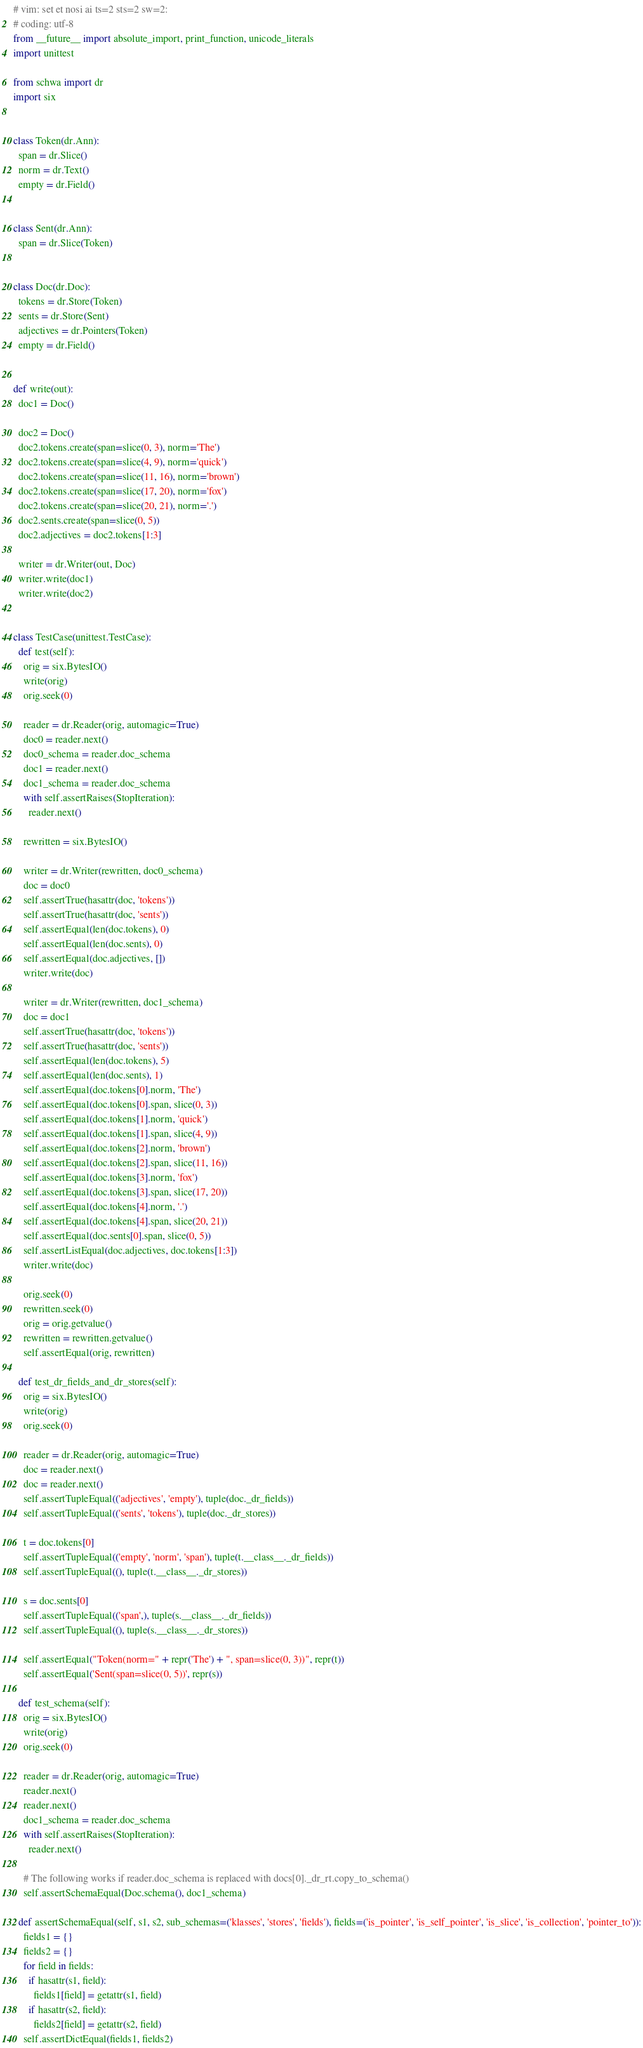Convert code to text. <code><loc_0><loc_0><loc_500><loc_500><_Python_># vim: set et nosi ai ts=2 sts=2 sw=2:
# coding: utf-8
from __future__ import absolute_import, print_function, unicode_literals
import unittest

from schwa import dr
import six


class Token(dr.Ann):
  span = dr.Slice()
  norm = dr.Text()
  empty = dr.Field()


class Sent(dr.Ann):
  span = dr.Slice(Token)


class Doc(dr.Doc):
  tokens = dr.Store(Token)
  sents = dr.Store(Sent)
  adjectives = dr.Pointers(Token)
  empty = dr.Field()


def write(out):
  doc1 = Doc()

  doc2 = Doc()
  doc2.tokens.create(span=slice(0, 3), norm='The')
  doc2.tokens.create(span=slice(4, 9), norm='quick')
  doc2.tokens.create(span=slice(11, 16), norm='brown')
  doc2.tokens.create(span=slice(17, 20), norm='fox')
  doc2.tokens.create(span=slice(20, 21), norm='.')
  doc2.sents.create(span=slice(0, 5))
  doc2.adjectives = doc2.tokens[1:3]

  writer = dr.Writer(out, Doc)
  writer.write(doc1)
  writer.write(doc2)


class TestCase(unittest.TestCase):
  def test(self):
    orig = six.BytesIO()
    write(orig)
    orig.seek(0)

    reader = dr.Reader(orig, automagic=True)
    doc0 = reader.next()
    doc0_schema = reader.doc_schema
    doc1 = reader.next()
    doc1_schema = reader.doc_schema
    with self.assertRaises(StopIteration):
      reader.next()

    rewritten = six.BytesIO()

    writer = dr.Writer(rewritten, doc0_schema)
    doc = doc0
    self.assertTrue(hasattr(doc, 'tokens'))
    self.assertTrue(hasattr(doc, 'sents'))
    self.assertEqual(len(doc.tokens), 0)
    self.assertEqual(len(doc.sents), 0)
    self.assertEqual(doc.adjectives, [])
    writer.write(doc)

    writer = dr.Writer(rewritten, doc1_schema)
    doc = doc1
    self.assertTrue(hasattr(doc, 'tokens'))
    self.assertTrue(hasattr(doc, 'sents'))
    self.assertEqual(len(doc.tokens), 5)
    self.assertEqual(len(doc.sents), 1)
    self.assertEqual(doc.tokens[0].norm, 'The')
    self.assertEqual(doc.tokens[0].span, slice(0, 3))
    self.assertEqual(doc.tokens[1].norm, 'quick')
    self.assertEqual(doc.tokens[1].span, slice(4, 9))
    self.assertEqual(doc.tokens[2].norm, 'brown')
    self.assertEqual(doc.tokens[2].span, slice(11, 16))
    self.assertEqual(doc.tokens[3].norm, 'fox')
    self.assertEqual(doc.tokens[3].span, slice(17, 20))
    self.assertEqual(doc.tokens[4].norm, '.')
    self.assertEqual(doc.tokens[4].span, slice(20, 21))
    self.assertEqual(doc.sents[0].span, slice(0, 5))
    self.assertListEqual(doc.adjectives, doc.tokens[1:3])
    writer.write(doc)

    orig.seek(0)
    rewritten.seek(0)
    orig = orig.getvalue()
    rewritten = rewritten.getvalue()
    self.assertEqual(orig, rewritten)

  def test_dr_fields_and_dr_stores(self):
    orig = six.BytesIO()
    write(orig)
    orig.seek(0)

    reader = dr.Reader(orig, automagic=True)
    doc = reader.next()
    doc = reader.next()
    self.assertTupleEqual(('adjectives', 'empty'), tuple(doc._dr_fields))
    self.assertTupleEqual(('sents', 'tokens'), tuple(doc._dr_stores))

    t = doc.tokens[0]
    self.assertTupleEqual(('empty', 'norm', 'span'), tuple(t.__class__._dr_fields))
    self.assertTupleEqual((), tuple(t.__class__._dr_stores))

    s = doc.sents[0]
    self.assertTupleEqual(('span',), tuple(s.__class__._dr_fields))
    self.assertTupleEqual((), tuple(s.__class__._dr_stores))

    self.assertEqual("Token(norm=" + repr('The') + ", span=slice(0, 3))", repr(t))
    self.assertEqual('Sent(span=slice(0, 5))', repr(s))

  def test_schema(self):
    orig = six.BytesIO()
    write(orig)
    orig.seek(0)

    reader = dr.Reader(orig, automagic=True)
    reader.next()
    reader.next()
    doc1_schema = reader.doc_schema
    with self.assertRaises(StopIteration):
      reader.next()

    # The following works if reader.doc_schema is replaced with docs[0]._dr_rt.copy_to_schema()
    self.assertSchemaEqual(Doc.schema(), doc1_schema)

  def assertSchemaEqual(self, s1, s2, sub_schemas=('klasses', 'stores', 'fields'), fields=('is_pointer', 'is_self_pointer', 'is_slice', 'is_collection', 'pointer_to')):
    fields1 = {}
    fields2 = {}
    for field in fields:
      if hasattr(s1, field):
        fields1[field] = getattr(s1, field)
      if hasattr(s2, field):
        fields2[field] = getattr(s2, field)
    self.assertDictEqual(fields1, fields2)
</code> 